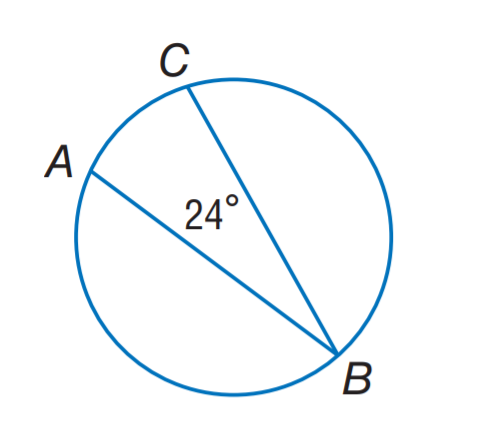Question: Find m \widehat A C.
Choices:
A. 12
B. 24
C. 48
D. 96
Answer with the letter. Answer: C 